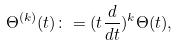<formula> <loc_0><loc_0><loc_500><loc_500>\Theta ^ { ( k ) } ( t ) \colon = ( t \frac { d } { d t } ) ^ { k } \Theta ( t ) ,</formula> 